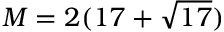<formula> <loc_0><loc_0><loc_500><loc_500>M = 2 ( 1 7 + { \sqrt { 1 7 } } )</formula> 